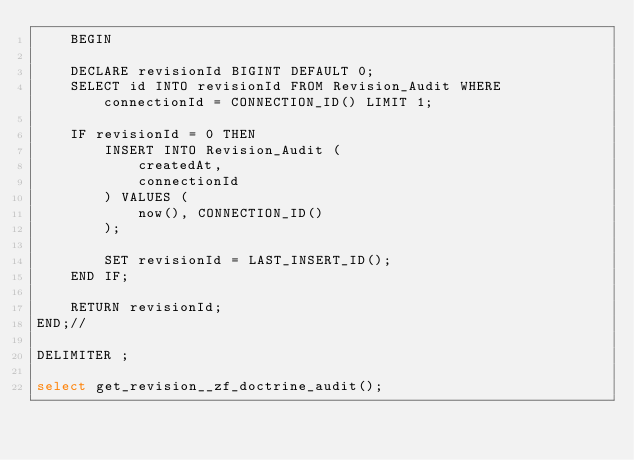Convert code to text. <code><loc_0><loc_0><loc_500><loc_500><_SQL_>    BEGIN

    DECLARE revisionId BIGINT DEFAULT 0;
    SELECT id INTO revisionId FROM Revision_Audit WHERE connectionId = CONNECTION_ID() LIMIT 1;

    IF revisionId = 0 THEN
        INSERT INTO Revision_Audit (
            createdAt,
            connectionId
        ) VALUES (
            now(), CONNECTION_ID()
        );

        SET revisionId = LAST_INSERT_ID();
    END IF;

    RETURN revisionId;
END;//

DELIMITER ;

select get_revision__zf_doctrine_audit();</code> 